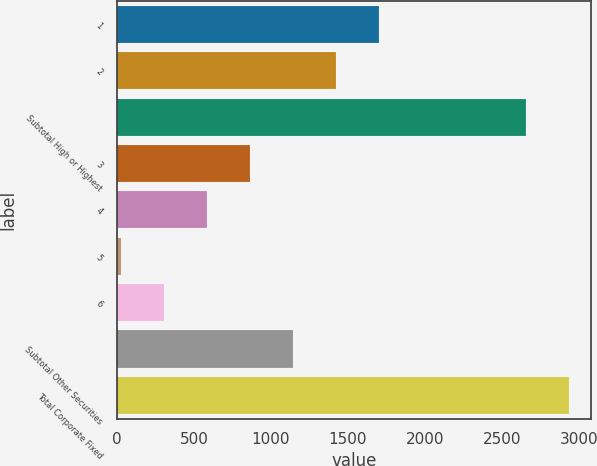<chart> <loc_0><loc_0><loc_500><loc_500><bar_chart><fcel>1<fcel>2<fcel>Subtotal High or Highest<fcel>3<fcel>4<fcel>5<fcel>6<fcel>Subtotal Other Securities<fcel>Total Corporate Fixed<nl><fcel>1700.4<fcel>1421<fcel>2655<fcel>862.2<fcel>582.8<fcel>24<fcel>303.4<fcel>1141.6<fcel>2934.4<nl></chart> 